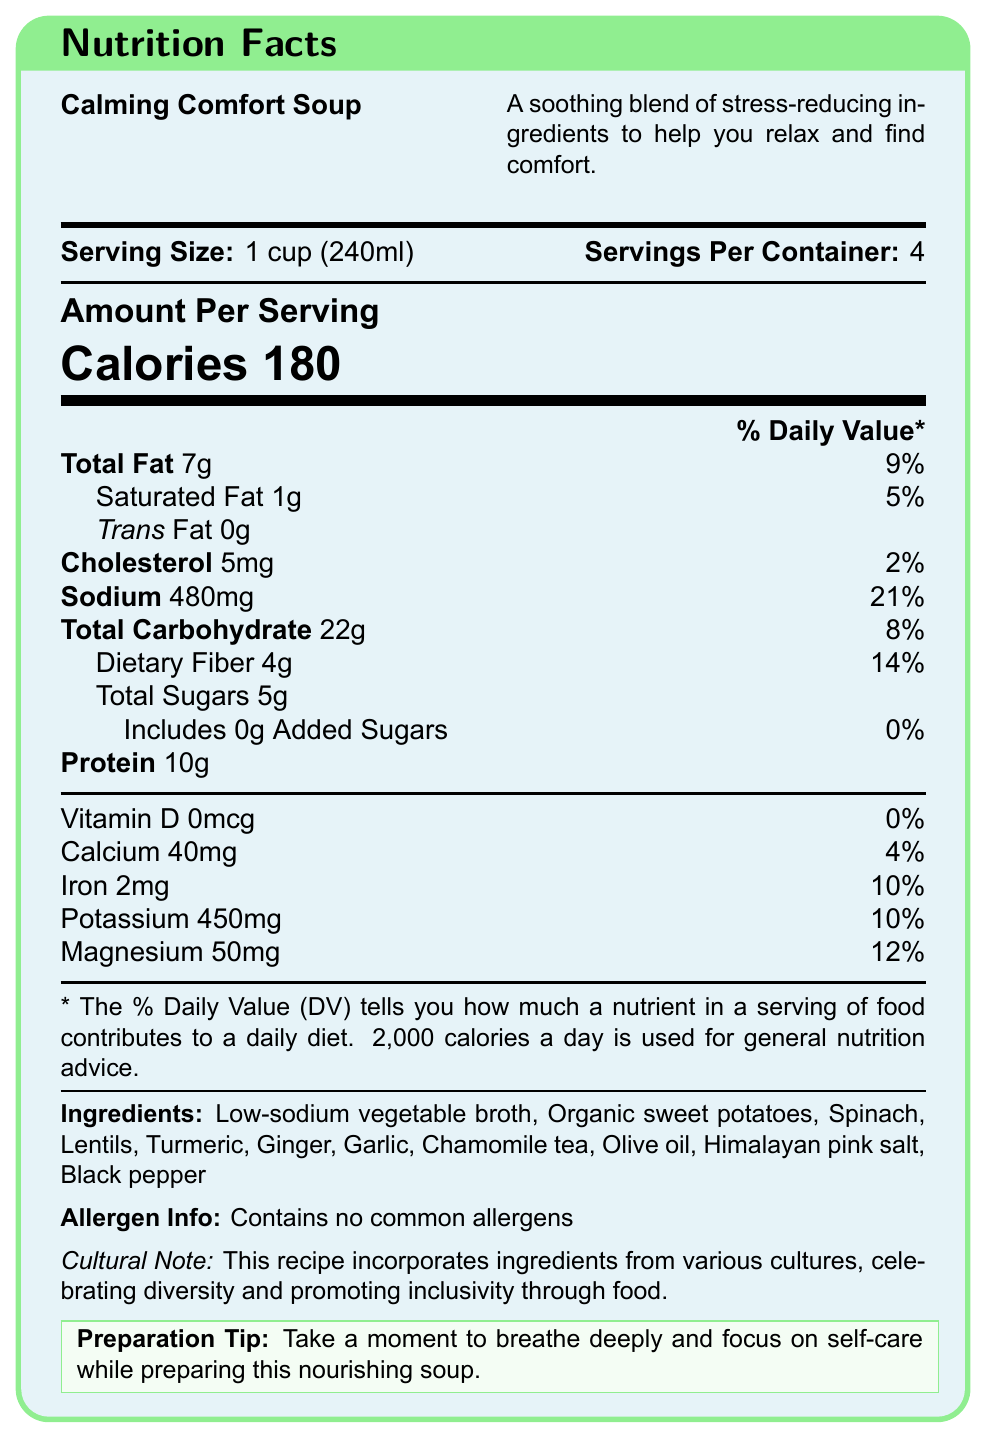what is the serving size of the Calming Comfort Soup? The document clearly states that the serving size is 1 cup (240ml).
Answer: 1 cup (240ml) how many servings are there per container? The document mentions that there are 4 servings per container.
Answer: 4 how many calories are in one serving of the soup? According to the document, each serving contains 180 calories.
Answer: 180 identify the amount of total fat in one serving The document lists the total fat content per serving as 7g.
Answer: 7g what is the percent daily value of sodium per serving? The document indicates that the sodium content per serving is 480mg, which is 21% of the daily value.
Answer: 21% which ingredient in the soup has stress-reducing properties? A. Organic sweet potatoes B. Spinach C. Chamomile tea D. Garlic Chamomile tea is known for its calming and stress-reducing properties, which aligns with the purpose of this recipe.
Answer: C. Chamomile tea what is the amount of protein per serving? The document specifies that there are 10g of protein per serving.
Answer: 10g is there any added sugar in the soup? The document states that the soup includes 0g of added sugars.
Answer: No true or false: The soup contains common allergens. The document clearly mentions that the soup contains no common allergens.
Answer: False summarize the main idea of the document. The label provides detailed nutritional information such as calories, fats, carbohydrates, protein, vitamins, and minerals per serving. It also lists the ingredients, states that the soup contains no common allergens, and includes a cultural note about inclusivity and a self-care preparation tip.
Answer: The document is a Nutrition Facts label for the "Calming Comfort Soup," which highlights its nutritional content and ingredients known for reducing stress and anxiety. what preparation tip does the document provide? The document includes a specific preparation tip encouraging self-care and mindfulness during the cooking process.
Answer: Take a moment to breathe deeply and focus on self-care while preparing this nourishing soup. what is the percent daily value of calcium per serving? The document indicates that each serving contains 40mg of calcium, which is 4% of the daily value.
Answer: 4% how much dietary fiber is in one serving? The document reveals that one serving contains 4g of dietary fiber.
Answer: 4g what is the recipe name and its description? The document names the recipe "Calming Comfort Soup" and describes it as a soothing blend that helps reduce stress and provides comfort.
Answer: Calming Comfort Soup; A soothing blend of stress-reducing ingredients to help you relax and find comfort. how much magnesium is there per serving? The document specifies that there are 50mg of magnesium per serving.
Answer: 50mg can the total iron amount in the entire container be calculated directly from the document? The document provides the iron content per serving (2mg) but does not give enough information to calculate the total iron amount for the entire container since it would require consideration of servings per container.
Answer: Not enough information how many grams of saturated fat are in one serving? According to the document, one serving contains 1g of saturated fat.
Answer: 1g what percent of the daily value of iron does one serving provide? The document indicates that one serving provides 2mg of iron, which is 10% of the daily value.
Answer: 10% which cultural note does the document reference regarding the recipe? A. Emphasizes family traditions B. Celebrates diversity and inclusivity C. Focuses on historical recipes D. Highlights festive occasions The document's cultural note mentions that the recipe incorporates ingredients from various cultures, celebrating diversity and promoting inclusivity through food.
Answer: B. Celebrates diversity and inclusivity what ingredient contributes to the immune-boosting properties of the soup? A. Himalayan pink salt B. Black pepper C. Turmeric D. Olive oil Turmeric is known for its immune-boosting properties. The document lists it as one of the ingredients in the soup.
Answer: C. Turmeric which vitamin is not present in the soup? The document mentions that vitamin D is present at 0mcg per serving, indicating its absence in the soup.
Answer: Vitamin D 